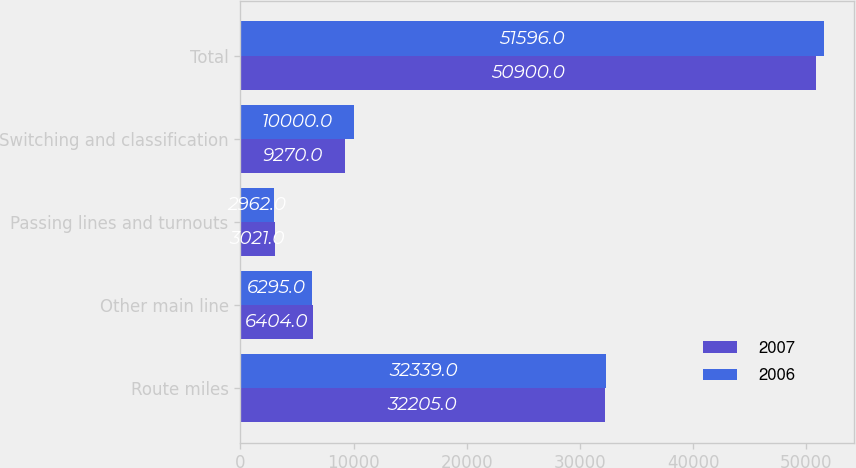Convert chart. <chart><loc_0><loc_0><loc_500><loc_500><stacked_bar_chart><ecel><fcel>Route miles<fcel>Other main line<fcel>Passing lines and turnouts<fcel>Switching and classification<fcel>Total<nl><fcel>2007<fcel>32205<fcel>6404<fcel>3021<fcel>9270<fcel>50900<nl><fcel>2006<fcel>32339<fcel>6295<fcel>2962<fcel>10000<fcel>51596<nl></chart> 